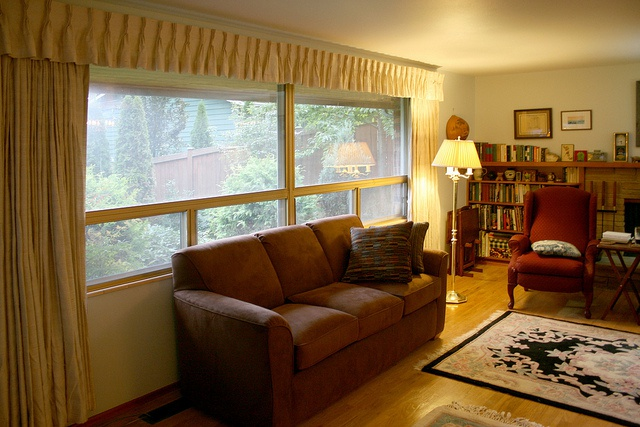Describe the objects in this image and their specific colors. I can see couch in maroon, black, and gray tones, chair in maroon, black, and tan tones, book in maroon, black, and olive tones, book in maroon, black, and olive tones, and book in maroon, black, and olive tones in this image. 